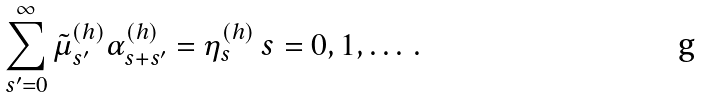<formula> <loc_0><loc_0><loc_500><loc_500>\sum _ { s ^ { \prime } = 0 } ^ { \infty } \tilde { \mu } _ { s ^ { \prime } } ^ { ( h ) } \alpha _ { s + s ^ { \prime } } ^ { ( h ) } = \eta _ { s } ^ { ( h ) } \, s = 0 , 1 , \dots \, .</formula> 